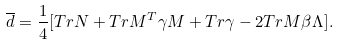<formula> <loc_0><loc_0><loc_500><loc_500>\overline { d } = \frac { 1 } { 4 } [ T r N + T r M ^ { T } \gamma M + T r \gamma - 2 T r M \beta \Lambda ] .</formula> 